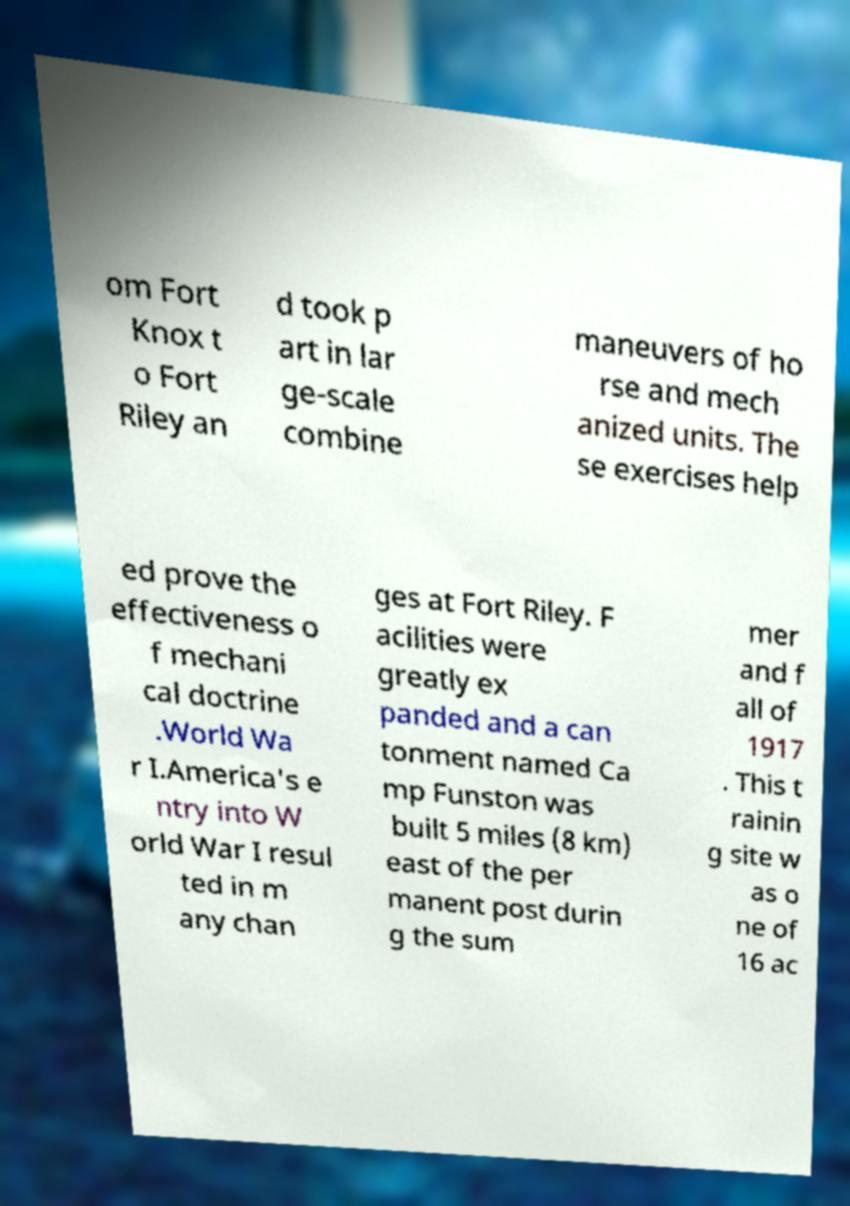I need the written content from this picture converted into text. Can you do that? om Fort Knox t o Fort Riley an d took p art in lar ge-scale combine maneuvers of ho rse and mech anized units. The se exercises help ed prove the effectiveness o f mechani cal doctrine .World Wa r I.America's e ntry into W orld War I resul ted in m any chan ges at Fort Riley. F acilities were greatly ex panded and a can tonment named Ca mp Funston was built 5 miles (8 km) east of the per manent post durin g the sum mer and f all of 1917 . This t rainin g site w as o ne of 16 ac 